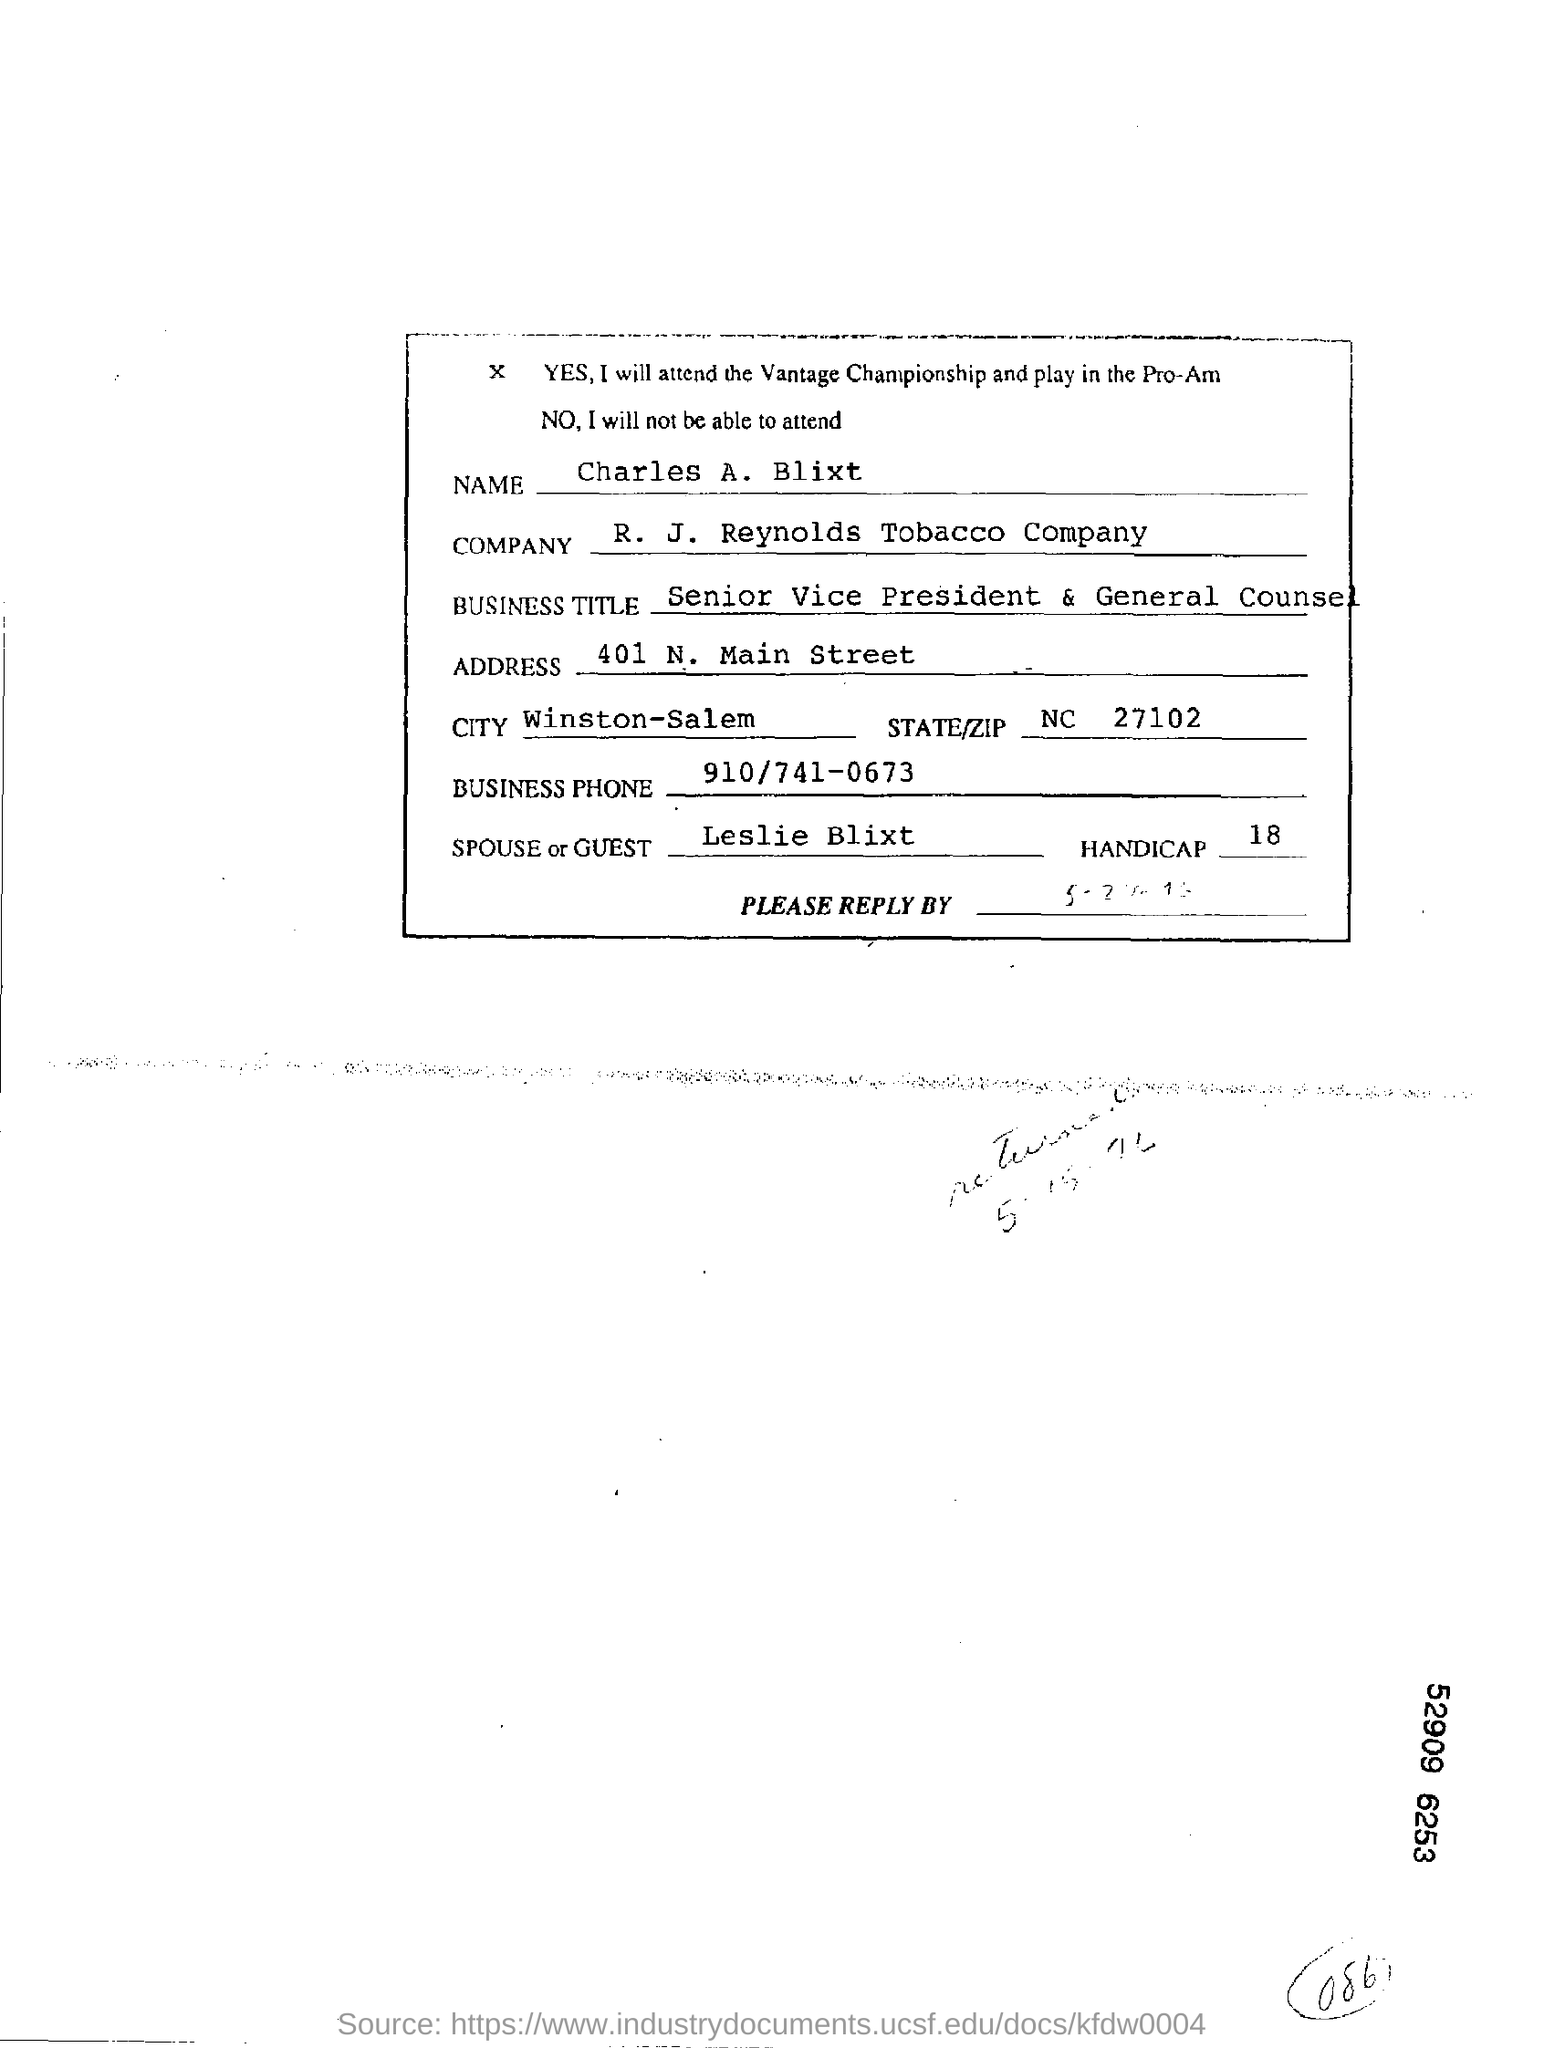Which company is mentioned in this document?
Your answer should be compact. R.  J.  Reynolds Tobacco Company. What is the STATE/ZIP mentioned in this document?
Your response must be concise. NC  27102. In which city does Charles A. Blixt belongs to?
Keep it short and to the point. Winston-Salem. What is the Business Phone no as per the document?
Make the answer very short. 910/741-0673. 